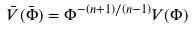Convert formula to latex. <formula><loc_0><loc_0><loc_500><loc_500>\bar { V } ( \bar { \Phi } ) = \Phi ^ { - ( n + 1 ) / ( n - 1 ) } V ( \Phi )</formula> 